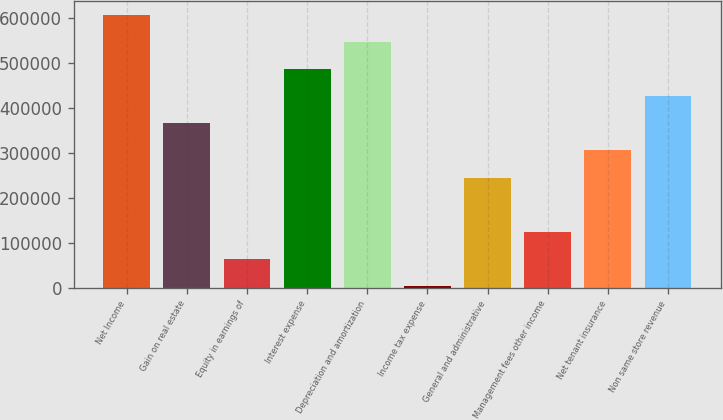<chart> <loc_0><loc_0><loc_500><loc_500><bar_chart><fcel>Net Income<fcel>Gain on real estate<fcel>Equity in earnings of<fcel>Interest expense<fcel>Depreciation and amortization<fcel>Income tax expense<fcel>General and administrative<fcel>Management fees other income<fcel>Net tenant insurance<fcel>Non same store revenue<nl><fcel>607100<fcel>365710<fcel>63972.5<fcel>486405<fcel>546752<fcel>3625<fcel>245015<fcel>124320<fcel>305362<fcel>426058<nl></chart> 